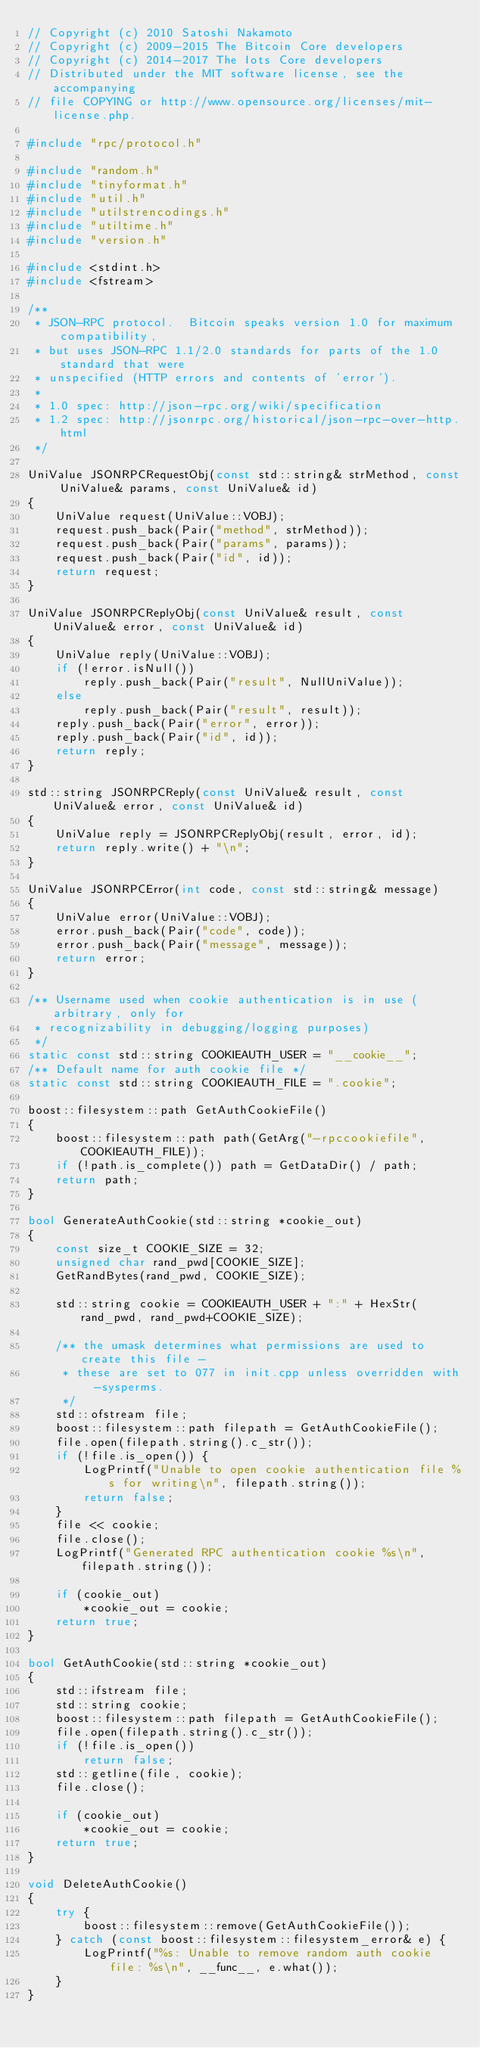<code> <loc_0><loc_0><loc_500><loc_500><_C++_>// Copyright (c) 2010 Satoshi Nakamoto
// Copyright (c) 2009-2015 The Bitcoin Core developers
// Copyright (c) 2014-2017 The Iots Core developers
// Distributed under the MIT software license, see the accompanying
// file COPYING or http://www.opensource.org/licenses/mit-license.php.

#include "rpc/protocol.h"

#include "random.h"
#include "tinyformat.h"
#include "util.h"
#include "utilstrencodings.h"
#include "utiltime.h"
#include "version.h"

#include <stdint.h>
#include <fstream>

/**
 * JSON-RPC protocol.  Bitcoin speaks version 1.0 for maximum compatibility,
 * but uses JSON-RPC 1.1/2.0 standards for parts of the 1.0 standard that were
 * unspecified (HTTP errors and contents of 'error').
 * 
 * 1.0 spec: http://json-rpc.org/wiki/specification
 * 1.2 spec: http://jsonrpc.org/historical/json-rpc-over-http.html
 */

UniValue JSONRPCRequestObj(const std::string& strMethod, const UniValue& params, const UniValue& id)
{
    UniValue request(UniValue::VOBJ);
    request.push_back(Pair("method", strMethod));
    request.push_back(Pair("params", params));
    request.push_back(Pair("id", id));
    return request;
}

UniValue JSONRPCReplyObj(const UniValue& result, const UniValue& error, const UniValue& id)
{
    UniValue reply(UniValue::VOBJ);
    if (!error.isNull())
        reply.push_back(Pair("result", NullUniValue));
    else
        reply.push_back(Pair("result", result));
    reply.push_back(Pair("error", error));
    reply.push_back(Pair("id", id));
    return reply;
}

std::string JSONRPCReply(const UniValue& result, const UniValue& error, const UniValue& id)
{
    UniValue reply = JSONRPCReplyObj(result, error, id);
    return reply.write() + "\n";
}

UniValue JSONRPCError(int code, const std::string& message)
{
    UniValue error(UniValue::VOBJ);
    error.push_back(Pair("code", code));
    error.push_back(Pair("message", message));
    return error;
}

/** Username used when cookie authentication is in use (arbitrary, only for
 * recognizability in debugging/logging purposes)
 */
static const std::string COOKIEAUTH_USER = "__cookie__";
/** Default name for auth cookie file */
static const std::string COOKIEAUTH_FILE = ".cookie";

boost::filesystem::path GetAuthCookieFile()
{
    boost::filesystem::path path(GetArg("-rpccookiefile", COOKIEAUTH_FILE));
    if (!path.is_complete()) path = GetDataDir() / path;
    return path;
}

bool GenerateAuthCookie(std::string *cookie_out)
{
    const size_t COOKIE_SIZE = 32;
    unsigned char rand_pwd[COOKIE_SIZE];
    GetRandBytes(rand_pwd, COOKIE_SIZE);

    std::string cookie = COOKIEAUTH_USER + ":" + HexStr(rand_pwd, rand_pwd+COOKIE_SIZE);

    /** the umask determines what permissions are used to create this file -
     * these are set to 077 in init.cpp unless overridden with -sysperms.
     */
    std::ofstream file;
    boost::filesystem::path filepath = GetAuthCookieFile();
    file.open(filepath.string().c_str());
    if (!file.is_open()) {
        LogPrintf("Unable to open cookie authentication file %s for writing\n", filepath.string());
        return false;
    }
    file << cookie;
    file.close();
    LogPrintf("Generated RPC authentication cookie %s\n", filepath.string());

    if (cookie_out)
        *cookie_out = cookie;
    return true;
}

bool GetAuthCookie(std::string *cookie_out)
{
    std::ifstream file;
    std::string cookie;
    boost::filesystem::path filepath = GetAuthCookieFile();
    file.open(filepath.string().c_str());
    if (!file.is_open())
        return false;
    std::getline(file, cookie);
    file.close();

    if (cookie_out)
        *cookie_out = cookie;
    return true;
}

void DeleteAuthCookie()
{
    try {
        boost::filesystem::remove(GetAuthCookieFile());
    } catch (const boost::filesystem::filesystem_error& e) {
        LogPrintf("%s: Unable to remove random auth cookie file: %s\n", __func__, e.what());
    }
}

</code> 